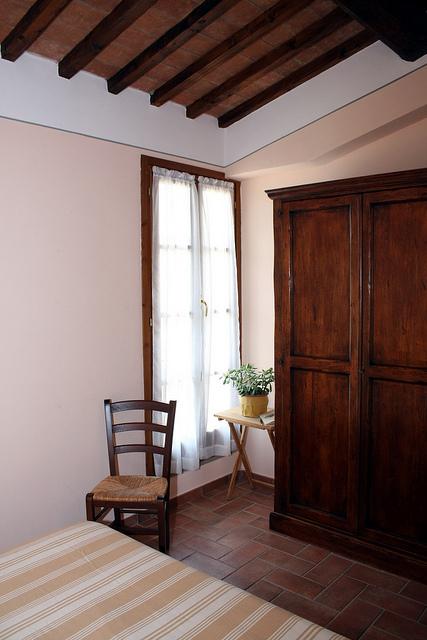Is this a hospital?
Quick response, please. No. What color is the cushion on the chair?
Give a very brief answer. Brown. Is this indoors?
Answer briefly. Yes. 